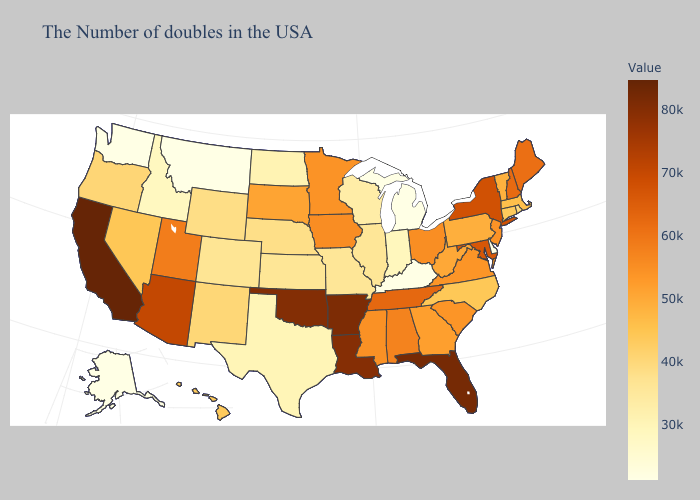Does California have the highest value in the USA?
Answer briefly. Yes. Does Maryland have a higher value than Oklahoma?
Quick response, please. No. Among the states that border Wyoming , which have the lowest value?
Write a very short answer. Montana. Does Hawaii have a higher value than South Dakota?
Be succinct. No. Is the legend a continuous bar?
Concise answer only. Yes. Which states have the highest value in the USA?
Keep it brief. California. 